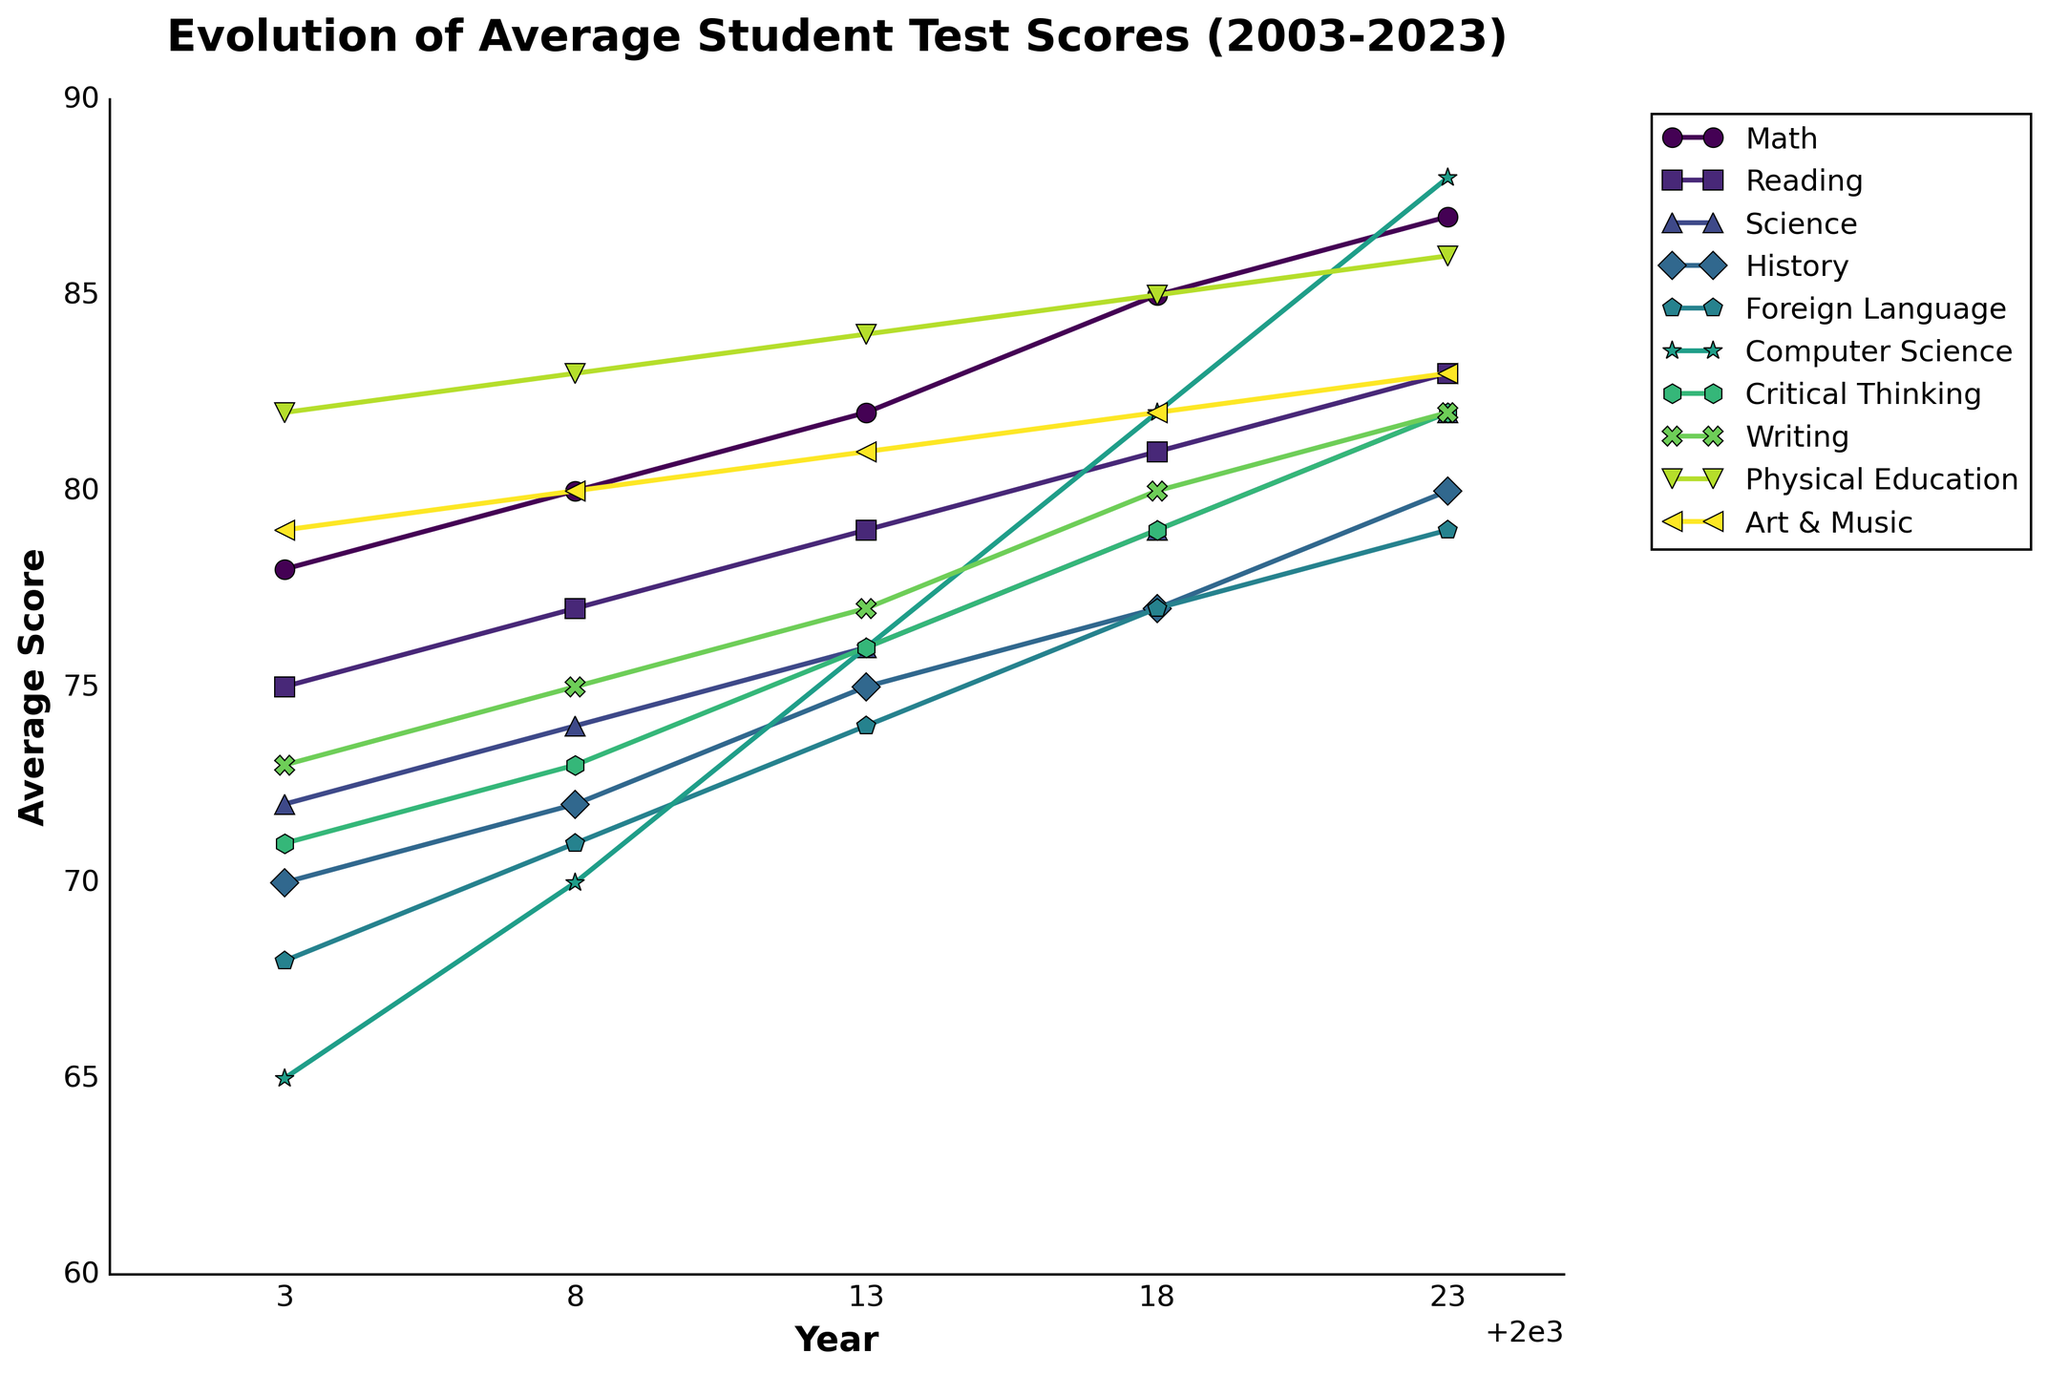what is the trend of average test scores in Math from 2003 to 2023? Math scores have consistently increased over the years: starting at 78 in 2003, 80 in 2008, 82 in 2013, 85 in 2018, and reaching 87 in 2023
Answer: consistently increasing Which subject showed the highest improvement in average test scores from 2003 to 2023? Calculate the difference for each subject from 2003 to 2023. Math: 87-78=9; Reading: 83-75=8; Science: 82-72=10; History: 80-70=10; Foreign Language: 79-68=11; Computer Science: 88-65=23; Critical Thinking: 82-71=11; Writing: 82-73=9; Physical Education: 86-82=4; Art & Music: 83-79=4. Computer Science shows the highest improvement
Answer: Computer Science Did any subjects have a constant increase in scores over every 5-year interval? Only by verifying each 5-year interval for all subjects: Math increased every interval from 2003 to 2023 (78, 80, 82, 85, 87), Reading increased every interval (75, 77, 79, 81, 83), etc. Most subjects show an increase every interval.
Answer: Yes Which year showed the smallest increase in average scores for Science compared to the previous recorded year? By comparing increases over different intervals: 2003-2008 (72 to 74 = 2), 2008-2013 (74 to 76 = 2), 2013-2018 (76 to 79 = 3), 2018-2023 (79 to 82 = 3). The increases in 2003-2008 and 2008-2013 are the smallest
Answer: 2003-2008 or 2008-2013 Which subjects had the same average score in 2023? Check 2023 column for identical scores: Science, Critical Thinking, and Writing all scored 82 in 2023
Answer: Science, Critical Thinking, Writing Comparing the score in 2003 and 2023, which subject shows the closest average score trend to Math? Calculate differences from Math trend (78 to 87 = 9): Reading (75 to 83 = 8), Science (72 to 82 = 10), History (70 to 80 = 10), etc. Science and History trends are closest to Math with a 10-point increase
Answer: Science, History In which subject did the average score surpass 80 the latest? Check which year each subject's score first surpassed 80: History in 2023; Foreign Language in 2023
Answer: Foreign Language What's the most frequent color tone used to represent the subjects? By visual inspection, color tones derived from the viridis colormap, mostly shades of green, are frequent
Answer: Green Which subject shows the smallest change in average scores from 2003 to 2023? Calculate changes over time for all subjects, Physical Education shows the smallest change from 82 to 86, which is 4 points
Answer: Physical Education In which subject is the 2023 score closest to the maximum possible average score of 90? Compare 2023 scores to 90, Computer Science has the highest score of 88, closest to 90
Answer: Computer Science 